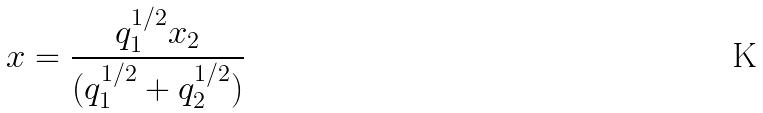<formula> <loc_0><loc_0><loc_500><loc_500>x = \frac { q _ { 1 } ^ { 1 / 2 } x _ { 2 } } { ( q _ { 1 } ^ { 1 / 2 } + q _ { 2 } ^ { 1 / 2 } ) }</formula> 